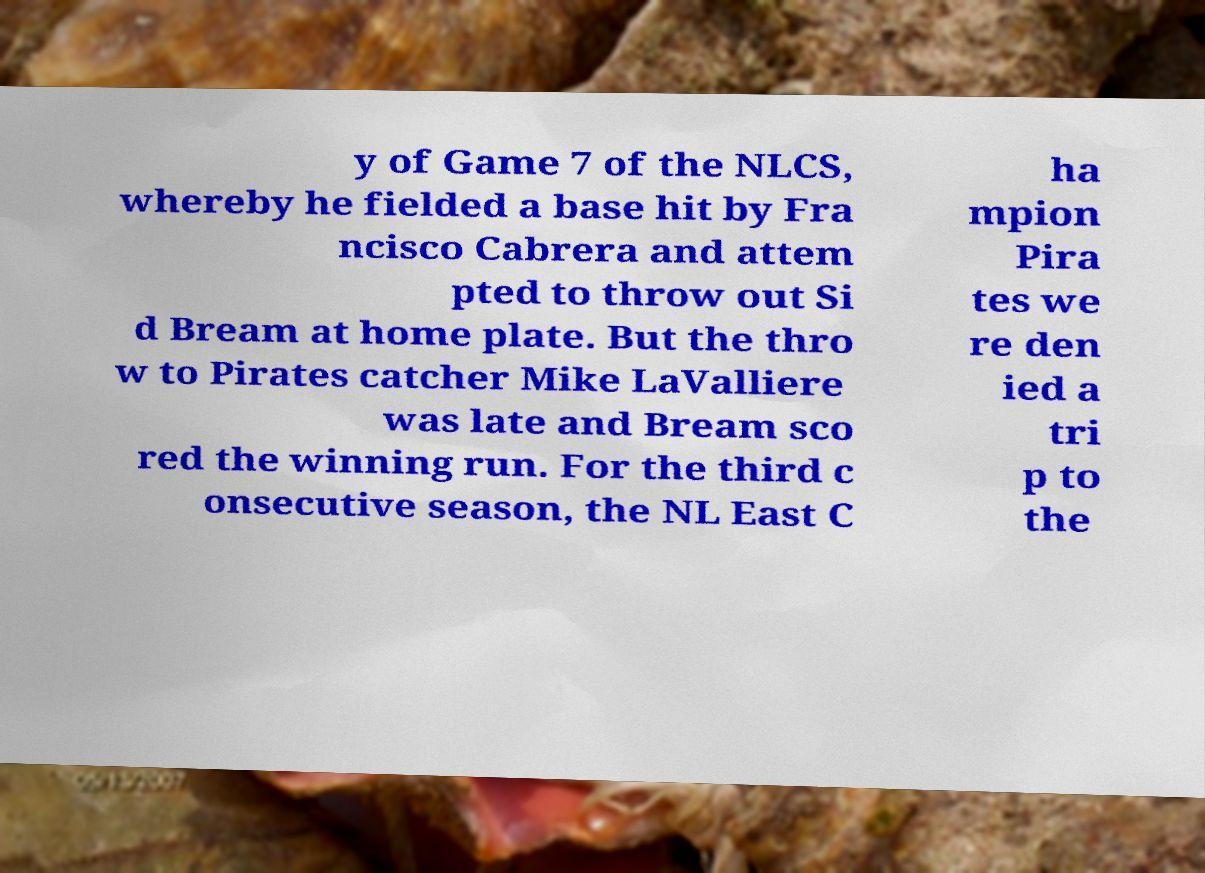There's text embedded in this image that I need extracted. Can you transcribe it verbatim? y of Game 7 of the NLCS, whereby he fielded a base hit by Fra ncisco Cabrera and attem pted to throw out Si d Bream at home plate. But the thro w to Pirates catcher Mike LaValliere was late and Bream sco red the winning run. For the third c onsecutive season, the NL East C ha mpion Pira tes we re den ied a tri p to the 